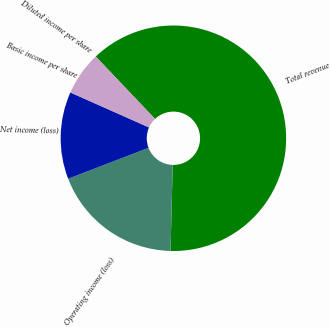Convert chart. <chart><loc_0><loc_0><loc_500><loc_500><pie_chart><fcel>Total revenue<fcel>Operating income (loss)<fcel>Net income (loss)<fcel>Basic income per share<fcel>Diluted income per share<nl><fcel>62.5%<fcel>18.75%<fcel>12.5%<fcel>0.0%<fcel>6.25%<nl></chart> 